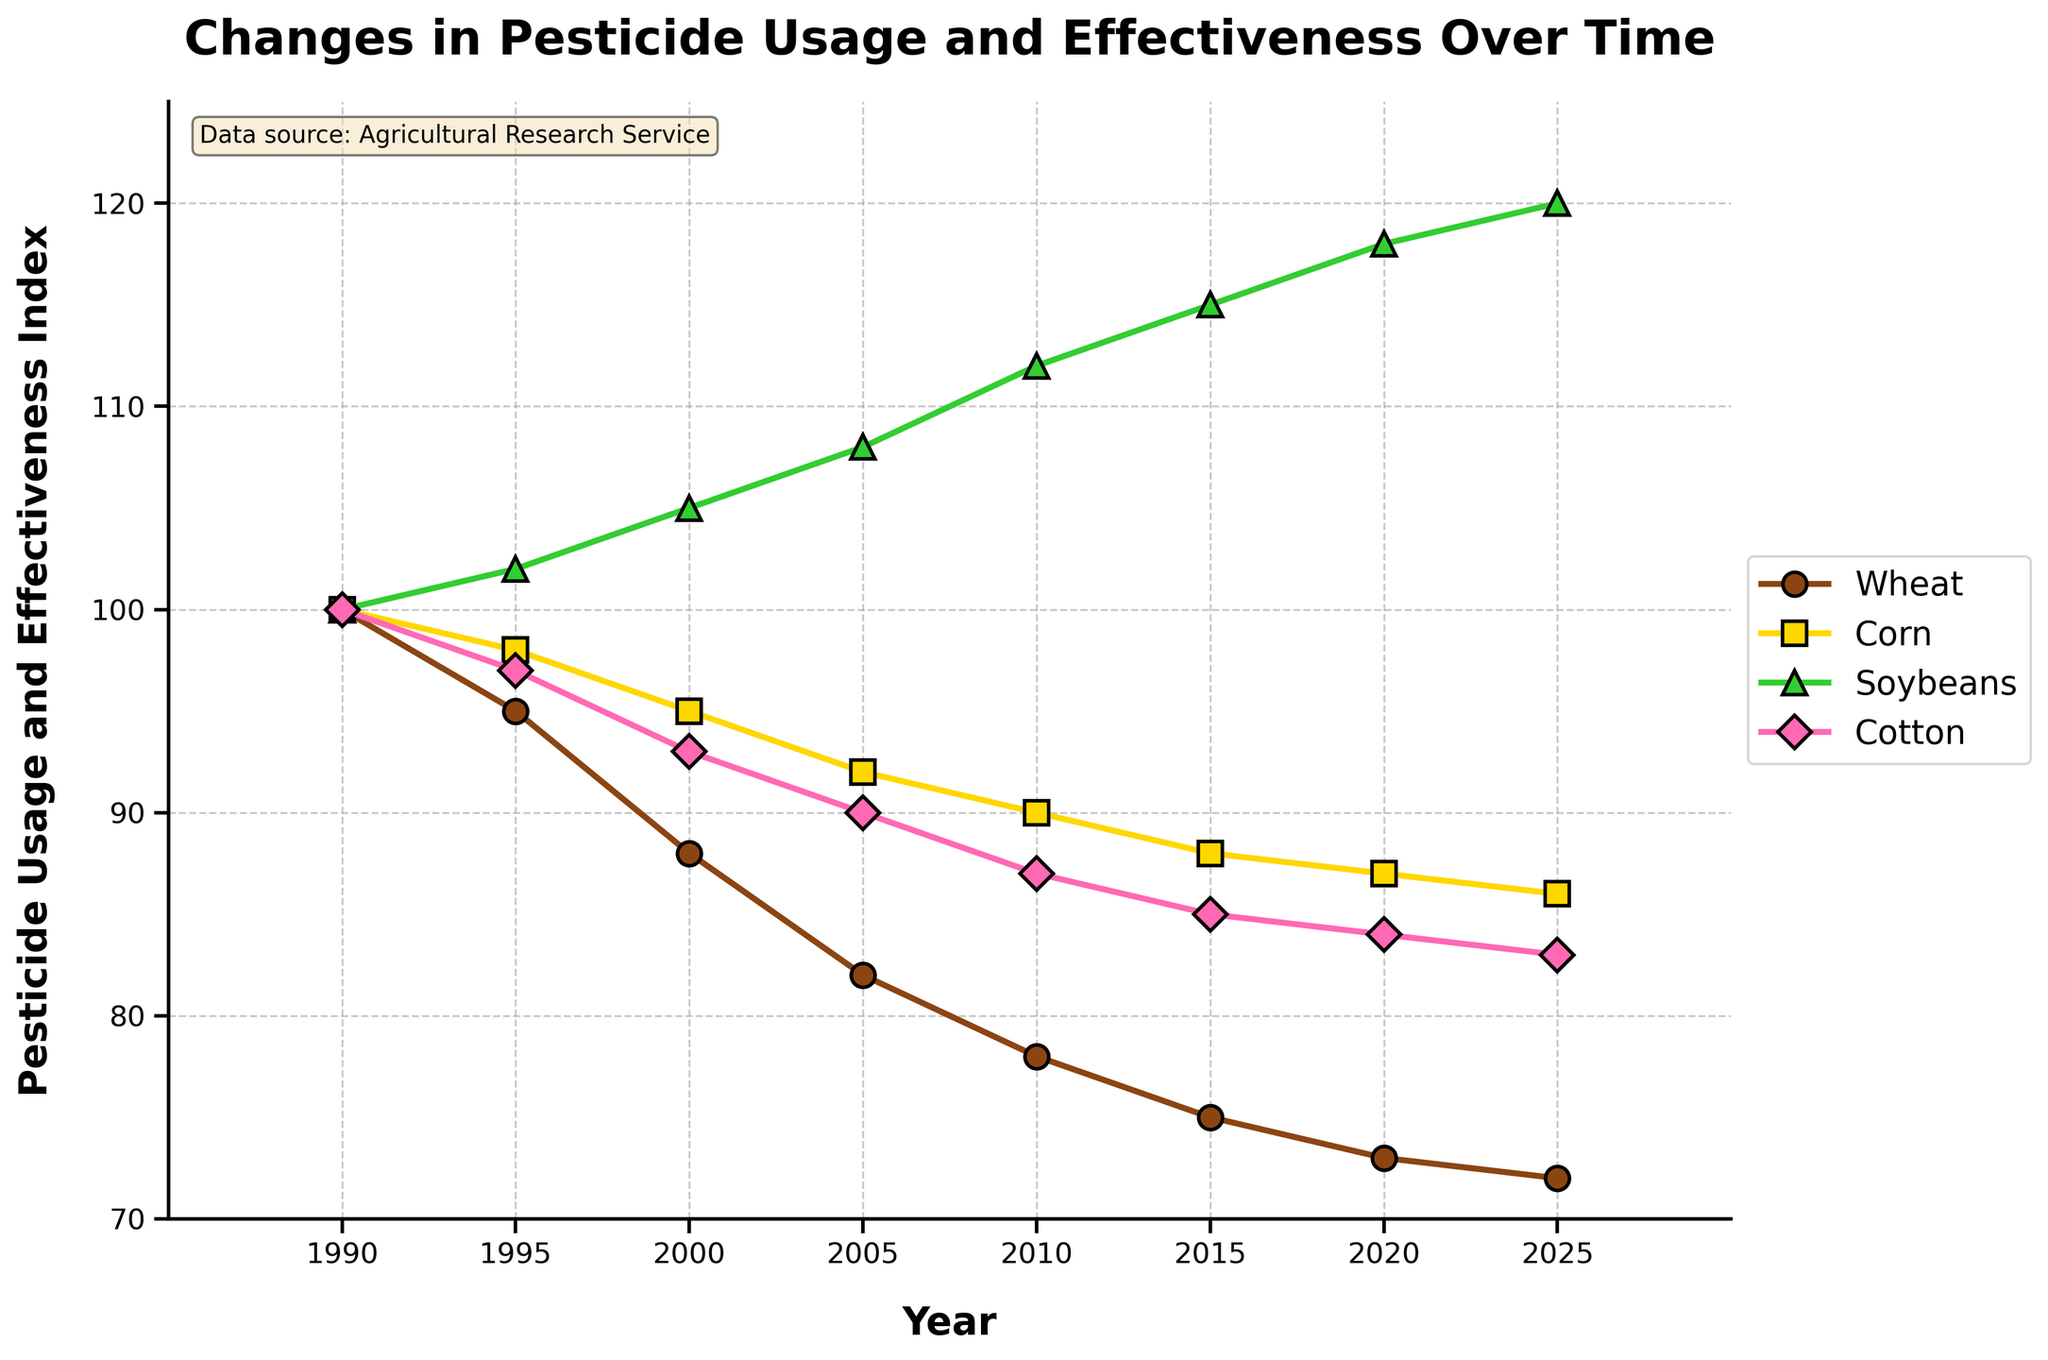What crop shows the highest increase in pesticide usage and effectiveness from 1990 to 2025? To find this, we need to look at the values for each crop in 1990 and 2025 and calculate the difference. Soybeans increase from 100 in 1990 to 120 in 2025, which is the highest increase of 20 units.
Answer: Soybeans Which crop had the lowest pesticide usage and effectiveness index in 2025? We need to check the values for each crop in the year 2025. The values are Wheat (72), Corn (86), Soybeans (120), Cotton (83). Wheat has the lowest value at 72.
Answer: Wheat By how much did the pesticide usage and effectiveness index for Cotton change from 1990 to 2005? To find this, subtract the 2005 value of Cotton (90) from the 1990 value (100). 100 - 90 = 10.
Answer: 10 When is the first year that the pesticide usage and effectiveness index for Wheat falls below 80? Checking the values for Wheat over the years, 2010 is the first year it drops below 80, standing at 78.
Answer: 2010 Compare the trends of pesticide usage and effectiveness for Soybeans and Corn between 2000 and 2020. Which crop increased more? Soybeans increase from 105 to 118 (an increase of 13), while Corn decreases from 95 to 87 (a decrease of 8). Soybeans increased more.
Answer: Soybeans What is the average pesticide usage and effectiveness index for Cotton from 1990 to 2025? The Cotton values are 100, 97, 93, 90, 87, 85, 84, 83. Sum them up (719) and divide by the number of data points (8). 719 / 8 ≈ 89.88.
Answer: 89.88 Which crop has an increasing trend from 1990 to 2025? By referring to the trend lines in the plot, only Soybeans show a continuous upward trend from 1990 to 2025.
Answer: Soybeans Is there any crop that shows a decline in pesticide usage and effectiveness every observed year? Wheat shows a continuous decline every observed year from 1990 to 2025.
Answer: Wheat In what year did Corn's pesticide usage and effectiveness index reach 90? Look at the points for Corn, it first reaches 90 in 2010.
Answer: 2010 